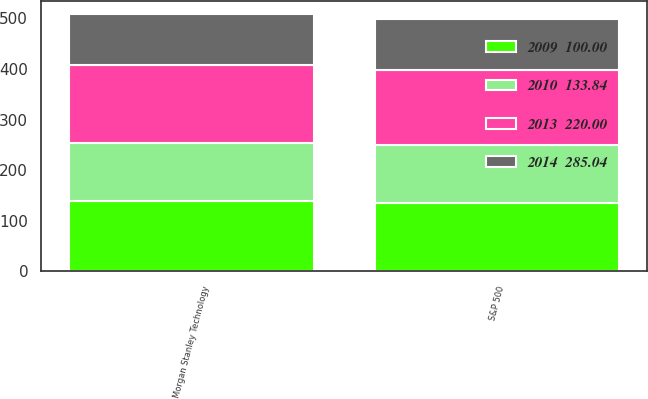Convert chart to OTSL. <chart><loc_0><loc_0><loc_500><loc_500><stacked_bar_chart><ecel><fcel>S&P 500<fcel>Morgan Stanley Technology<nl><fcel>2014  285.04<fcel>100<fcel>100<nl><fcel>2010  133.84<fcel>113.83<fcel>113.68<nl><fcel>2009  100.00<fcel>136.21<fcel>139.39<nl><fcel>2013  220.00<fcel>148.64<fcel>155.12<nl></chart> 